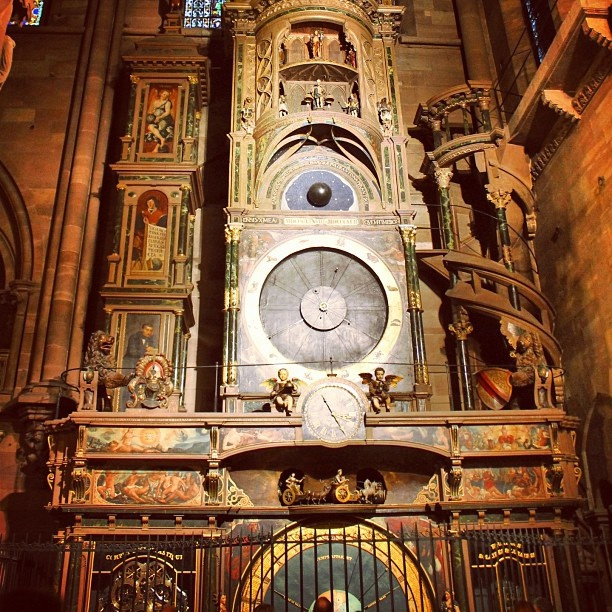Describe the objects in this image and their specific colors. I can see clock in red, ivory, darkgray, and tan tones, clock in brown, ivory, and tan tones, people in red, maroon, black, and olive tones, and people in maroon, red, and black tones in this image. 